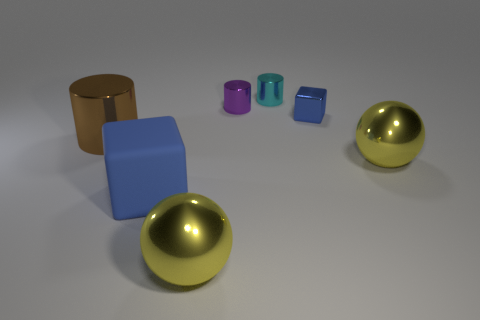If I were to group the objects based on height, how would they be categorized? Based on height, you can categorize the objects into two groups: the tall objects, which include the brown cylinder and blue cube, and the short objects, comprising the purple, teal, and green cubes along with the two golden spheres. 